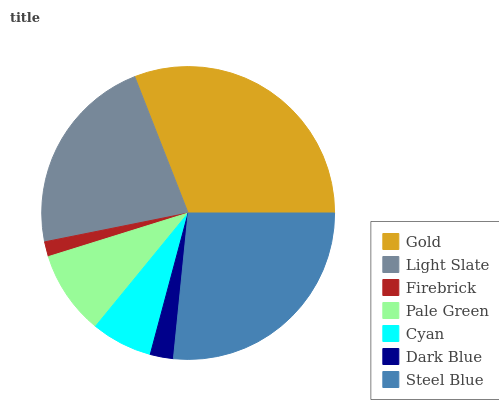Is Firebrick the minimum?
Answer yes or no. Yes. Is Gold the maximum?
Answer yes or no. Yes. Is Light Slate the minimum?
Answer yes or no. No. Is Light Slate the maximum?
Answer yes or no. No. Is Gold greater than Light Slate?
Answer yes or no. Yes. Is Light Slate less than Gold?
Answer yes or no. Yes. Is Light Slate greater than Gold?
Answer yes or no. No. Is Gold less than Light Slate?
Answer yes or no. No. Is Pale Green the high median?
Answer yes or no. Yes. Is Pale Green the low median?
Answer yes or no. Yes. Is Firebrick the high median?
Answer yes or no. No. Is Light Slate the low median?
Answer yes or no. No. 